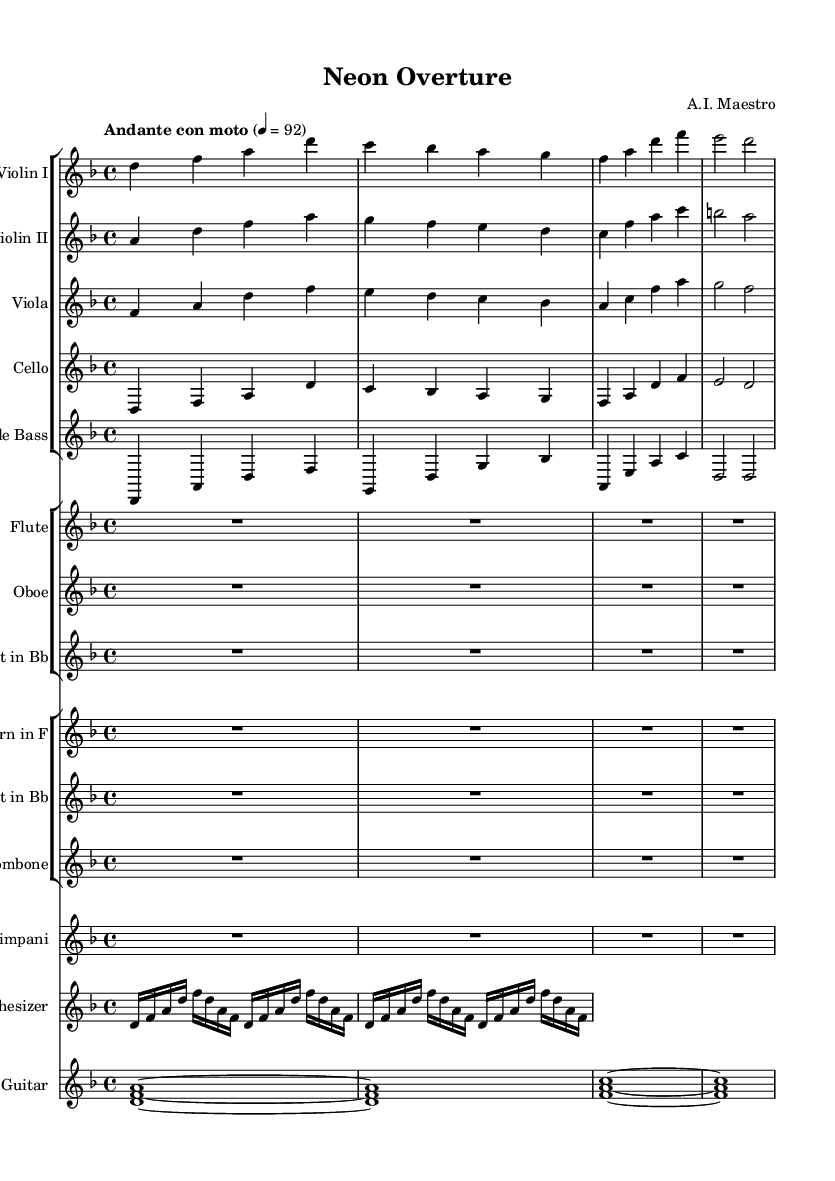What is the key signature of this music? The key signature is indicated by the number of sharps or flats at the beginning of the staff. Here, it shows one flat, which corresponds to the key of D minor.
Answer: D minor What is the time signature of this music? The time signature is listed at the beginning of the staff as a fraction. In this case, it shows 4/4, which means there are four beats in each measure and a quarter note gets one beat.
Answer: 4/4 What is the tempo marking for this piece? The tempo marking appears at the beginning of the sheet music, indicating how fast the piece should be played. It states 'Andante con moto,' which suggests a moderate pace.
Answer: Andante con moto How many measures are in the first violin part? To determine this, you can count the number of bar lines in the violin part. In this case, there are four measures indicated before it goes to the next part.
Answer: 4 Which instrument plays the synth part? The synthesizer part is noted with the label 'Synthesizer' in the score. It is specifically shown on its own staff under the PianoStaff grouping, indicating it is played alongside the piano parts.
Answer: Synthesizer What type of instruments accompany the orchestra in this score? The score features a mix of orchestral and electronic instruments. The electronic instruments present are the synthesizer and electric guitar, which add an innovative touch to the overall orchestration.
Answer: Synthesizer and Electric Guitar What is the most significant thematic element introduced by the synthesizer? By analyzing the rhythmic and melodic patterns in the synthesizer part, one can notice an innovative use of electronic sound that enhances the orchestral texture and creates a unique atmosphere. The repetitive figures suggest they may serve as a key thematic motive.
Answer: Repetitive figures 